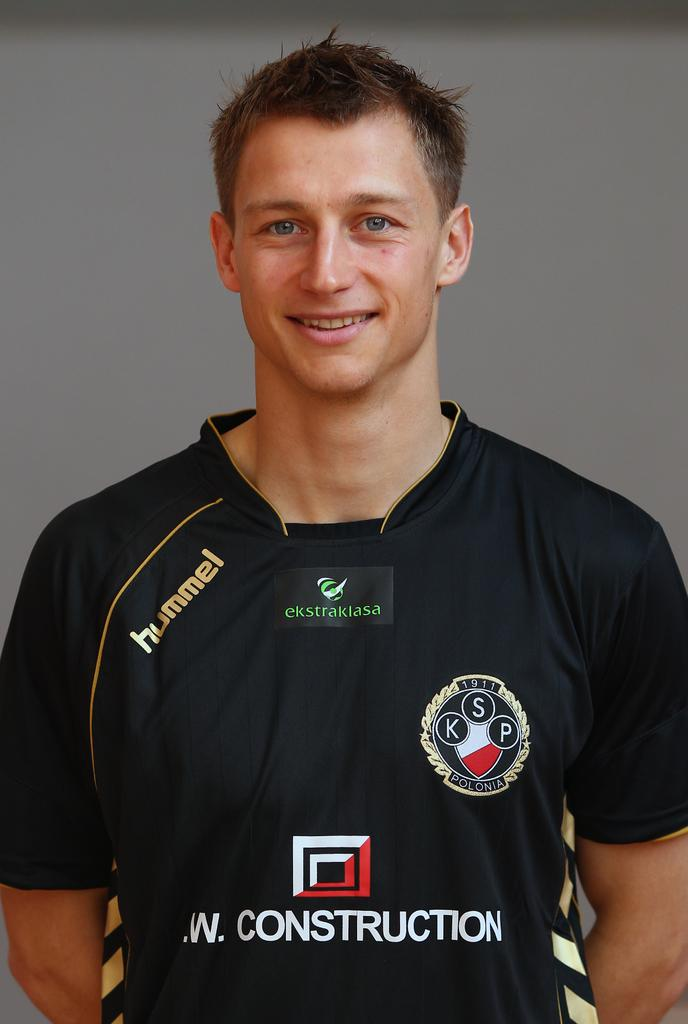<image>
Relay a brief, clear account of the picture shown. Man with a black shirt that has the word hummel in gold. 